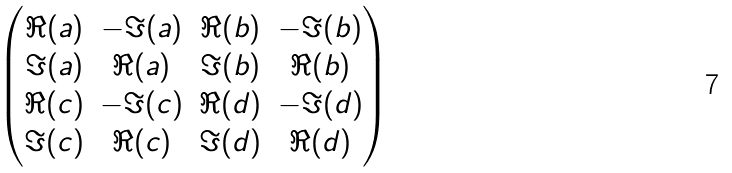<formula> <loc_0><loc_0><loc_500><loc_500>\begin{pmatrix} \Re { ( a ) } & - \Im { ( a ) } & \Re { ( b ) } & - \Im { ( b ) } \\ \Im { ( a ) } & \Re { ( a ) } & \Im { ( b ) } & \Re { ( b ) } \\ \Re { ( c ) } & - \Im { ( c ) } & \Re { ( d ) } & - \Im { ( d ) } \\ \Im { ( c ) } & \Re { ( c ) } & \Im { ( d ) } & \Re { ( d ) } \\ \end{pmatrix}</formula> 